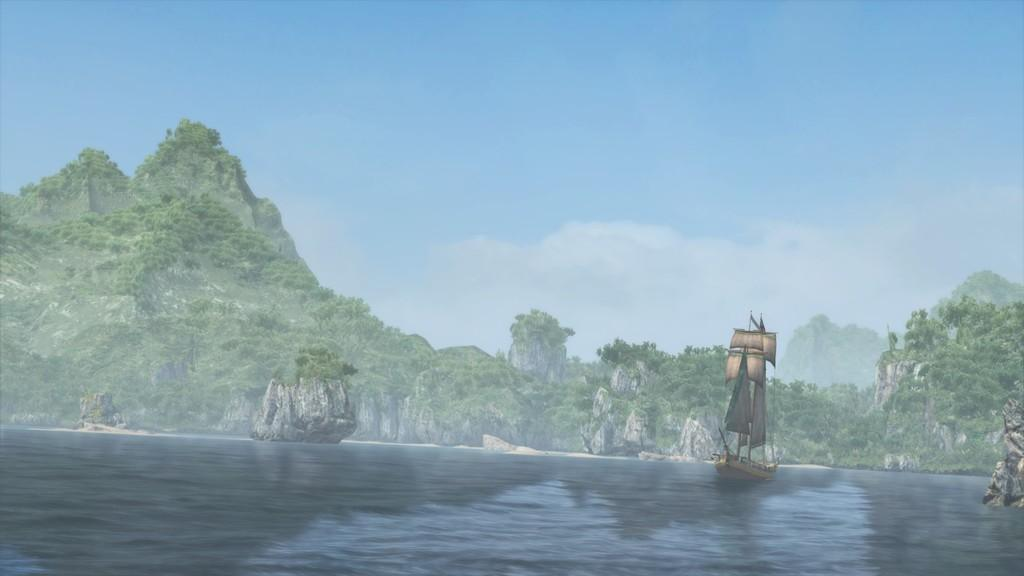What is the main subject of the image? There is a boat in the image. What can be seen in the water near the boat? There are rocks on the water in the image. What type of natural environment is visible in the image? Trees and hills are present in the image. How would you describe the weather in the image? The sky is cloudy in the image. Where is the notebook placed in the image? There is no notebook present in the image. What type of flowers can be seen in the garden in the image? There is no garden present in the image. 